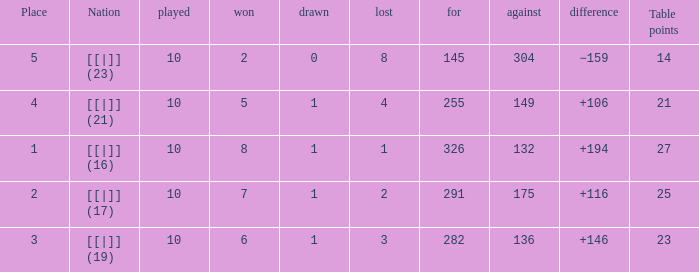Parse the full table. {'header': ['Place', 'Nation', 'played', 'won', 'drawn', 'lost', 'for', 'against', 'difference', 'Table points'], 'rows': [['5', '[[|]] (23)', '10', '2', '0', '8', '145', '304', '−159', '14'], ['4', '[[|]] (21)', '10', '5', '1', '4', '255', '149', '+106', '21'], ['1', '[[|]] (16)', '10', '8', '1', '1', '326', '132', '+194', '27'], ['2', '[[|]] (17)', '10', '7', '1', '2', '291', '175', '+116', '25'], ['3', '[[|]] (19)', '10', '6', '1', '3', '282', '136', '+146', '23']]}  How many table points are listed for the deficit is +194?  1.0. 